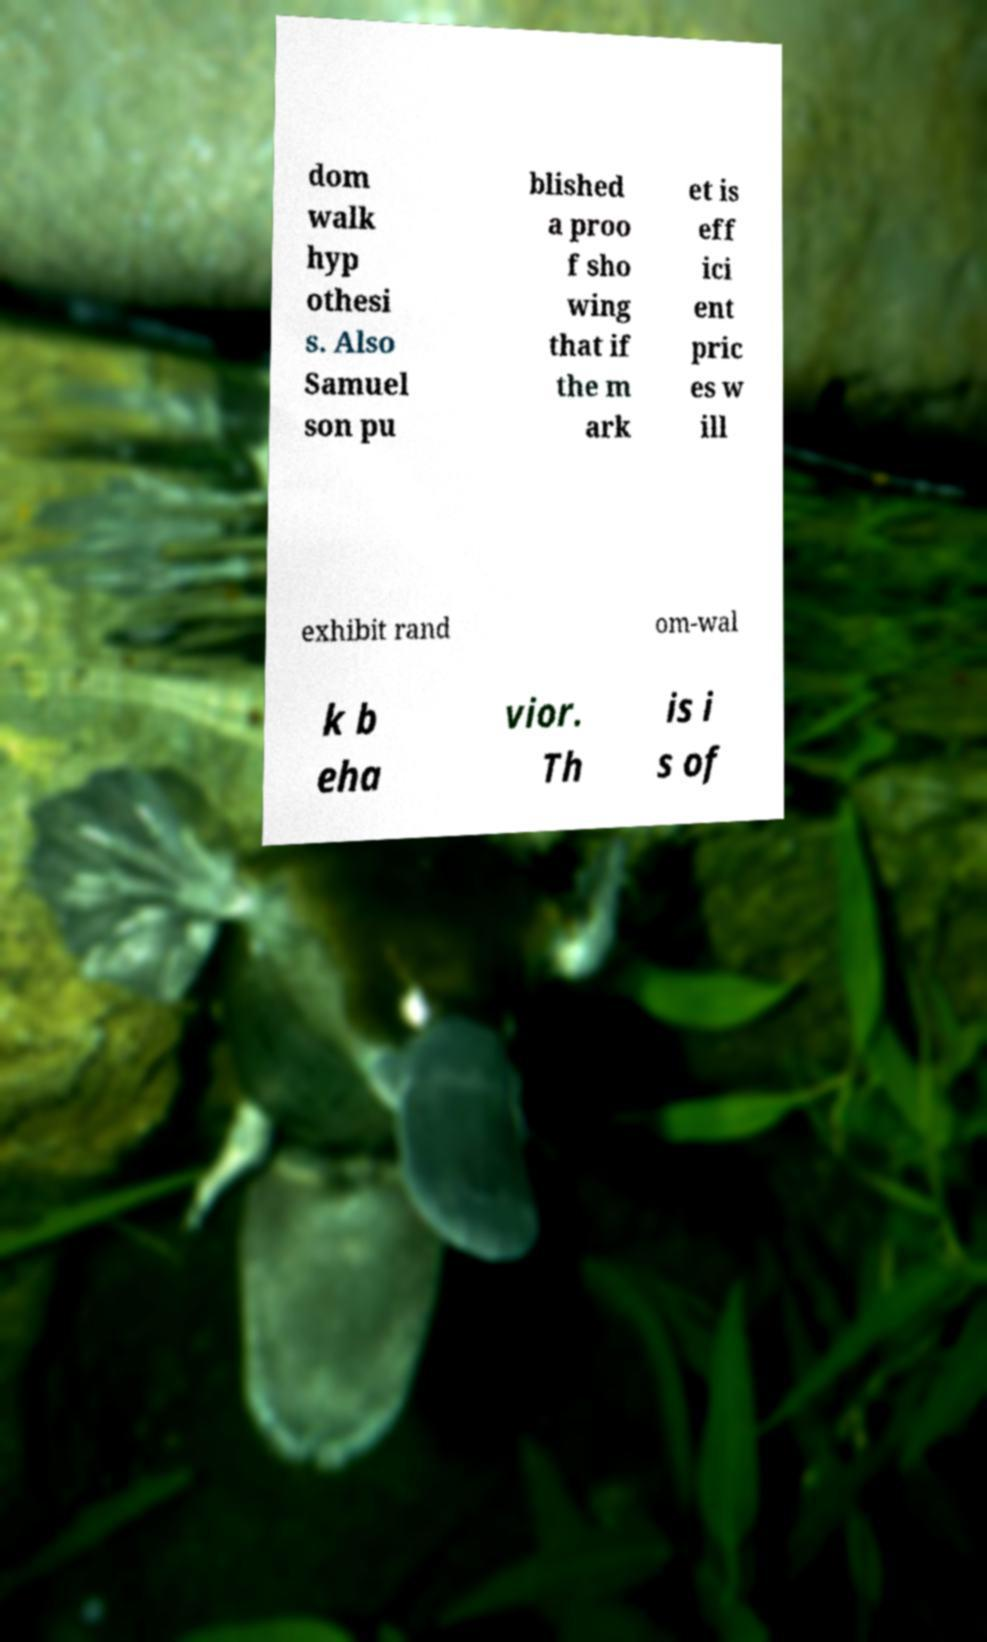There's text embedded in this image that I need extracted. Can you transcribe it verbatim? dom walk hyp othesi s. Also Samuel son pu blished a proo f sho wing that if the m ark et is eff ici ent pric es w ill exhibit rand om-wal k b eha vior. Th is i s of 